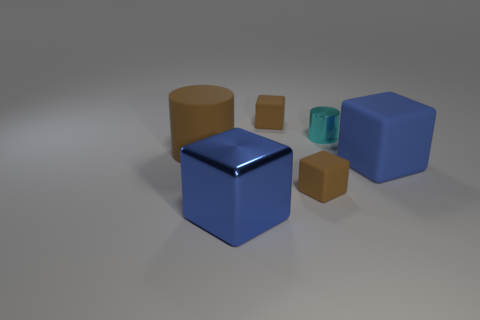Subtract all gray cubes. Subtract all red cylinders. How many cubes are left? 4 Add 2 large cylinders. How many objects exist? 8 Subtract 1 brown cylinders. How many objects are left? 5 Subtract all cubes. How many objects are left? 2 Subtract all large blue cubes. Subtract all large blue shiny objects. How many objects are left? 3 Add 4 matte cylinders. How many matte cylinders are left? 5 Add 4 large cyan metallic cubes. How many large cyan metallic cubes exist? 4 